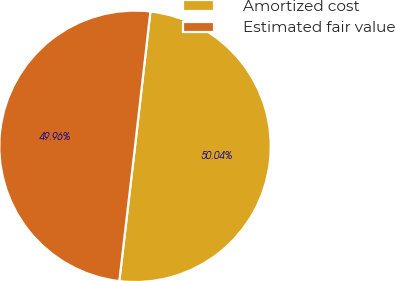Convert chart. <chart><loc_0><loc_0><loc_500><loc_500><pie_chart><fcel>Amortized cost<fcel>Estimated fair value<nl><fcel>50.04%<fcel>49.96%<nl></chart> 